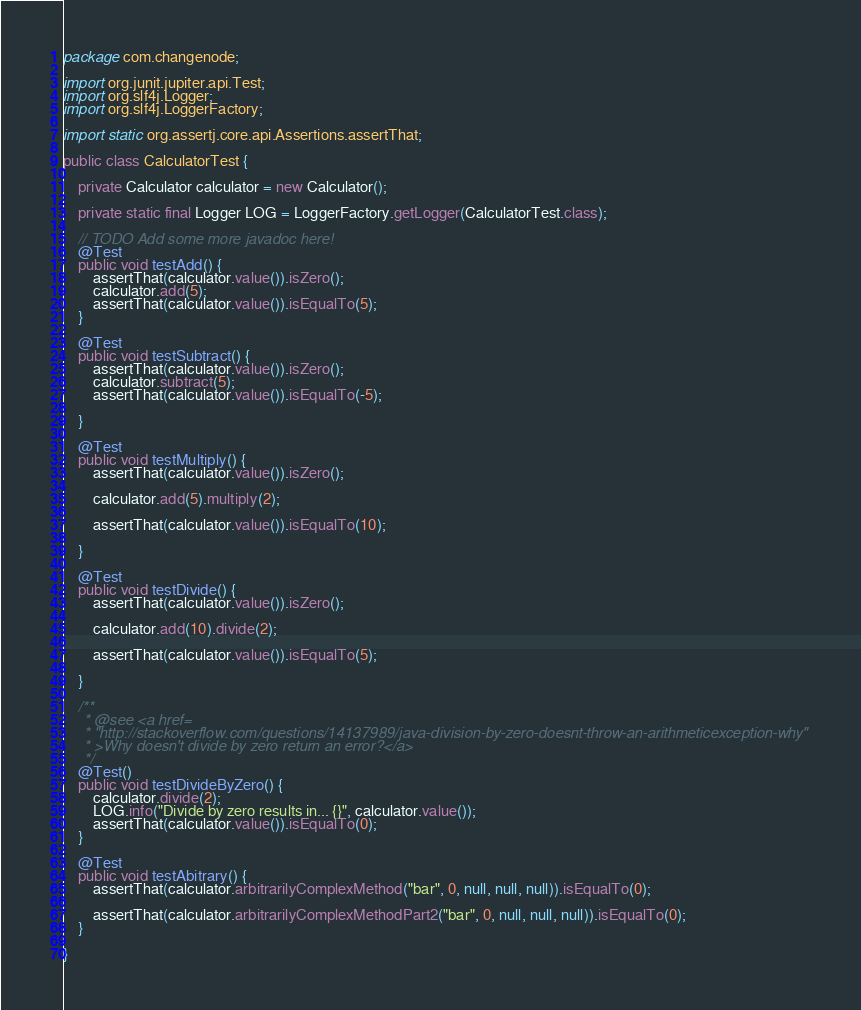<code> <loc_0><loc_0><loc_500><loc_500><_Java_>package com.changenode;

import org.junit.jupiter.api.Test;
import org.slf4j.Logger;
import org.slf4j.LoggerFactory;

import static org.assertj.core.api.Assertions.assertThat;

public class CalculatorTest {

    private Calculator calculator = new Calculator();

    private static final Logger LOG = LoggerFactory.getLogger(CalculatorTest.class);

    // TODO Add some more javadoc here!
    @Test
    public void testAdd() {
        assertThat(calculator.value()).isZero();
        calculator.add(5);
        assertThat(calculator.value()).isEqualTo(5);
    }

    @Test
    public void testSubtract() {
        assertThat(calculator.value()).isZero();
        calculator.subtract(5);
        assertThat(calculator.value()).isEqualTo(-5);

    }

    @Test
    public void testMultiply() {
        assertThat(calculator.value()).isZero();

        calculator.add(5).multiply(2);

        assertThat(calculator.value()).isEqualTo(10);

    }

    @Test
    public void testDivide() {
        assertThat(calculator.value()).isZero();

        calculator.add(10).divide(2);

        assertThat(calculator.value()).isEqualTo(5);

    }

    /**
     * @see <a href=
     * "http://stackoverflow.com/questions/14137989/java-division-by-zero-doesnt-throw-an-arithmeticexception-why"
     * >Why doesn't divide by zero return an error?</a>
     */
    @Test()
    public void testDivideByZero() {
        calculator.divide(2);
        LOG.info("Divide by zero results in... {}", calculator.value());
        assertThat(calculator.value()).isEqualTo(0);
    }

    @Test
    public void testAbitrary() {
        assertThat(calculator.arbitrarilyComplexMethod("bar", 0, null, null, null)).isEqualTo(0);

        assertThat(calculator.arbitrarilyComplexMethodPart2("bar", 0, null, null, null)).isEqualTo(0);
    }

}
</code> 